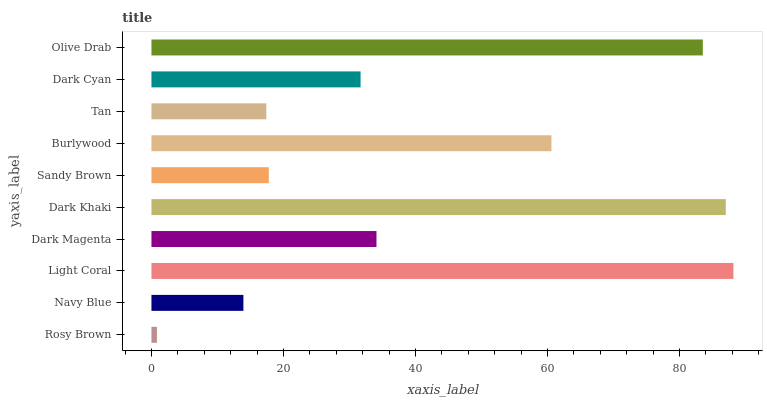Is Rosy Brown the minimum?
Answer yes or no. Yes. Is Light Coral the maximum?
Answer yes or no. Yes. Is Navy Blue the minimum?
Answer yes or no. No. Is Navy Blue the maximum?
Answer yes or no. No. Is Navy Blue greater than Rosy Brown?
Answer yes or no. Yes. Is Rosy Brown less than Navy Blue?
Answer yes or no. Yes. Is Rosy Brown greater than Navy Blue?
Answer yes or no. No. Is Navy Blue less than Rosy Brown?
Answer yes or no. No. Is Dark Magenta the high median?
Answer yes or no. Yes. Is Dark Cyan the low median?
Answer yes or no. Yes. Is Burlywood the high median?
Answer yes or no. No. Is Dark Magenta the low median?
Answer yes or no. No. 